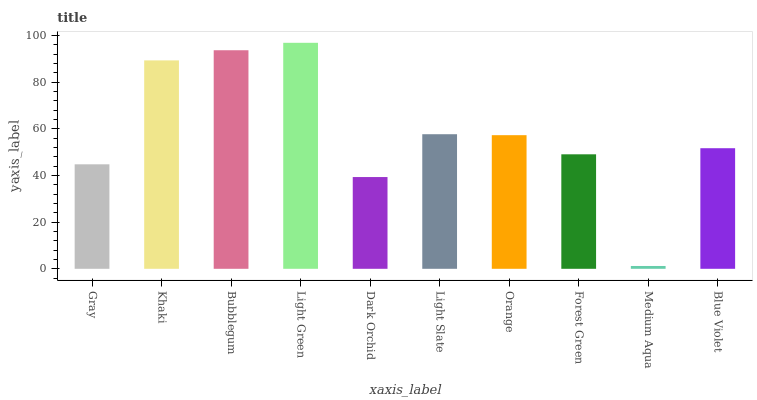Is Medium Aqua the minimum?
Answer yes or no. Yes. Is Light Green the maximum?
Answer yes or no. Yes. Is Khaki the minimum?
Answer yes or no. No. Is Khaki the maximum?
Answer yes or no. No. Is Khaki greater than Gray?
Answer yes or no. Yes. Is Gray less than Khaki?
Answer yes or no. Yes. Is Gray greater than Khaki?
Answer yes or no. No. Is Khaki less than Gray?
Answer yes or no. No. Is Orange the high median?
Answer yes or no. Yes. Is Blue Violet the low median?
Answer yes or no. Yes. Is Forest Green the high median?
Answer yes or no. No. Is Forest Green the low median?
Answer yes or no. No. 